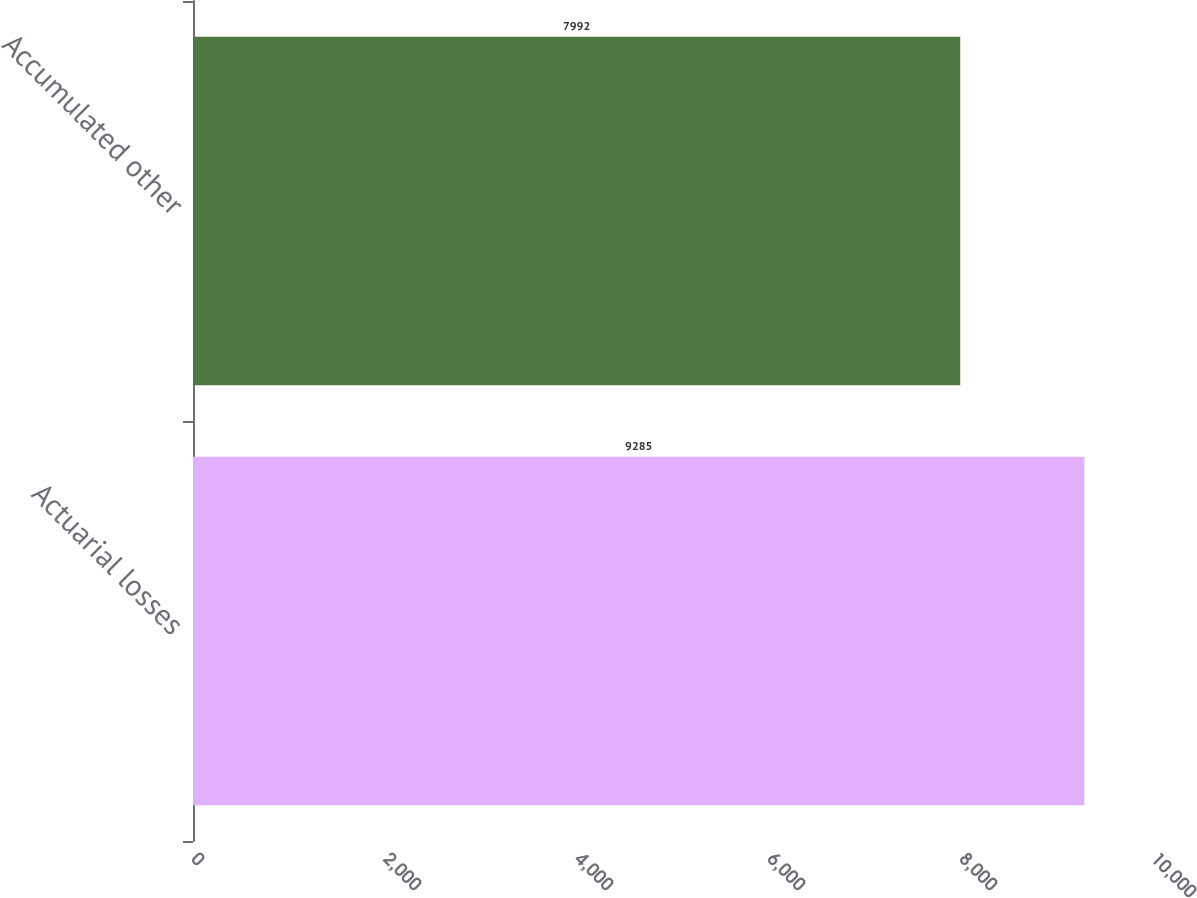Convert chart to OTSL. <chart><loc_0><loc_0><loc_500><loc_500><bar_chart><fcel>Actuarial losses<fcel>Accumulated other<nl><fcel>9285<fcel>7992<nl></chart> 